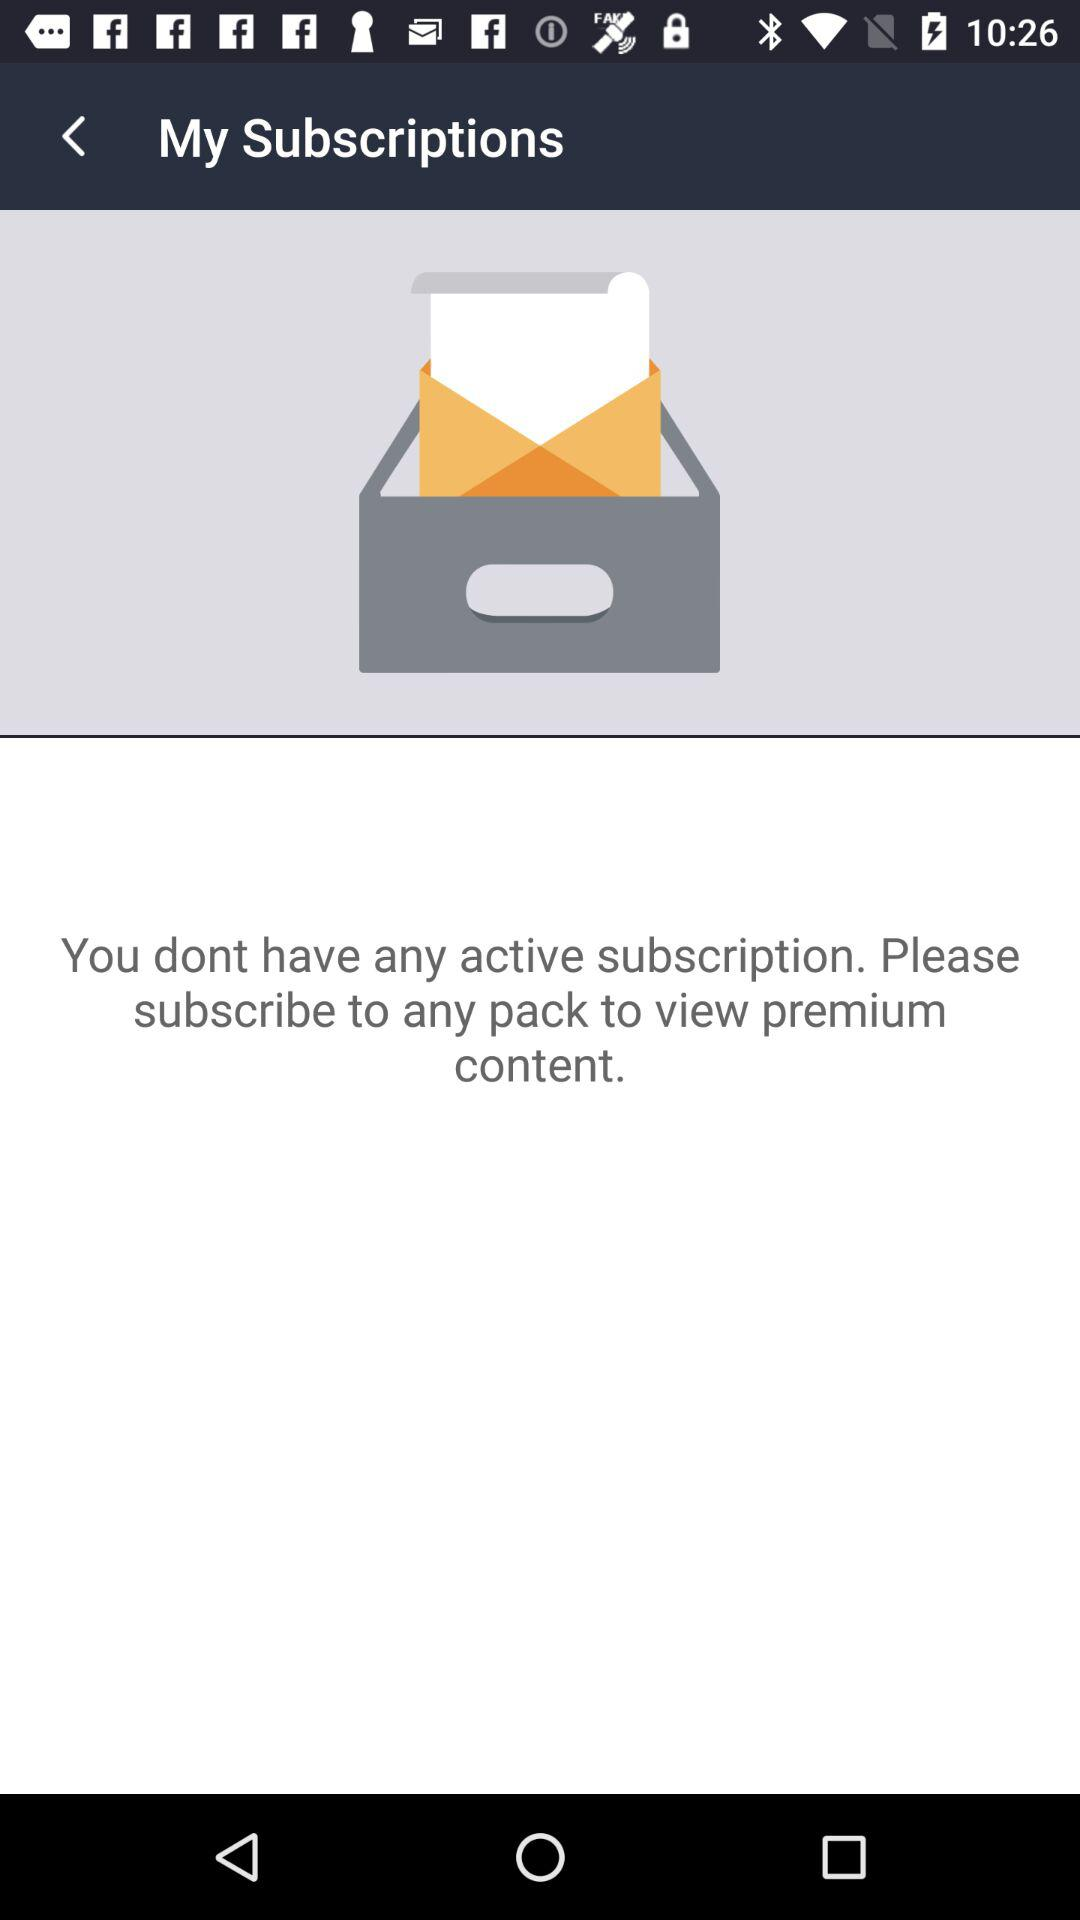How can I subscribe to a pack to view premium content, as suggested in the message? To subscribe to a pack and view premium content, you will typically have to navigate within the app or website to find the subscriptions or memberships section. From there, you can choose the desired pack and follow the on-screen instructions to complete your subscription, which may involve selecting a payment method and agreeing to the terms of service. 